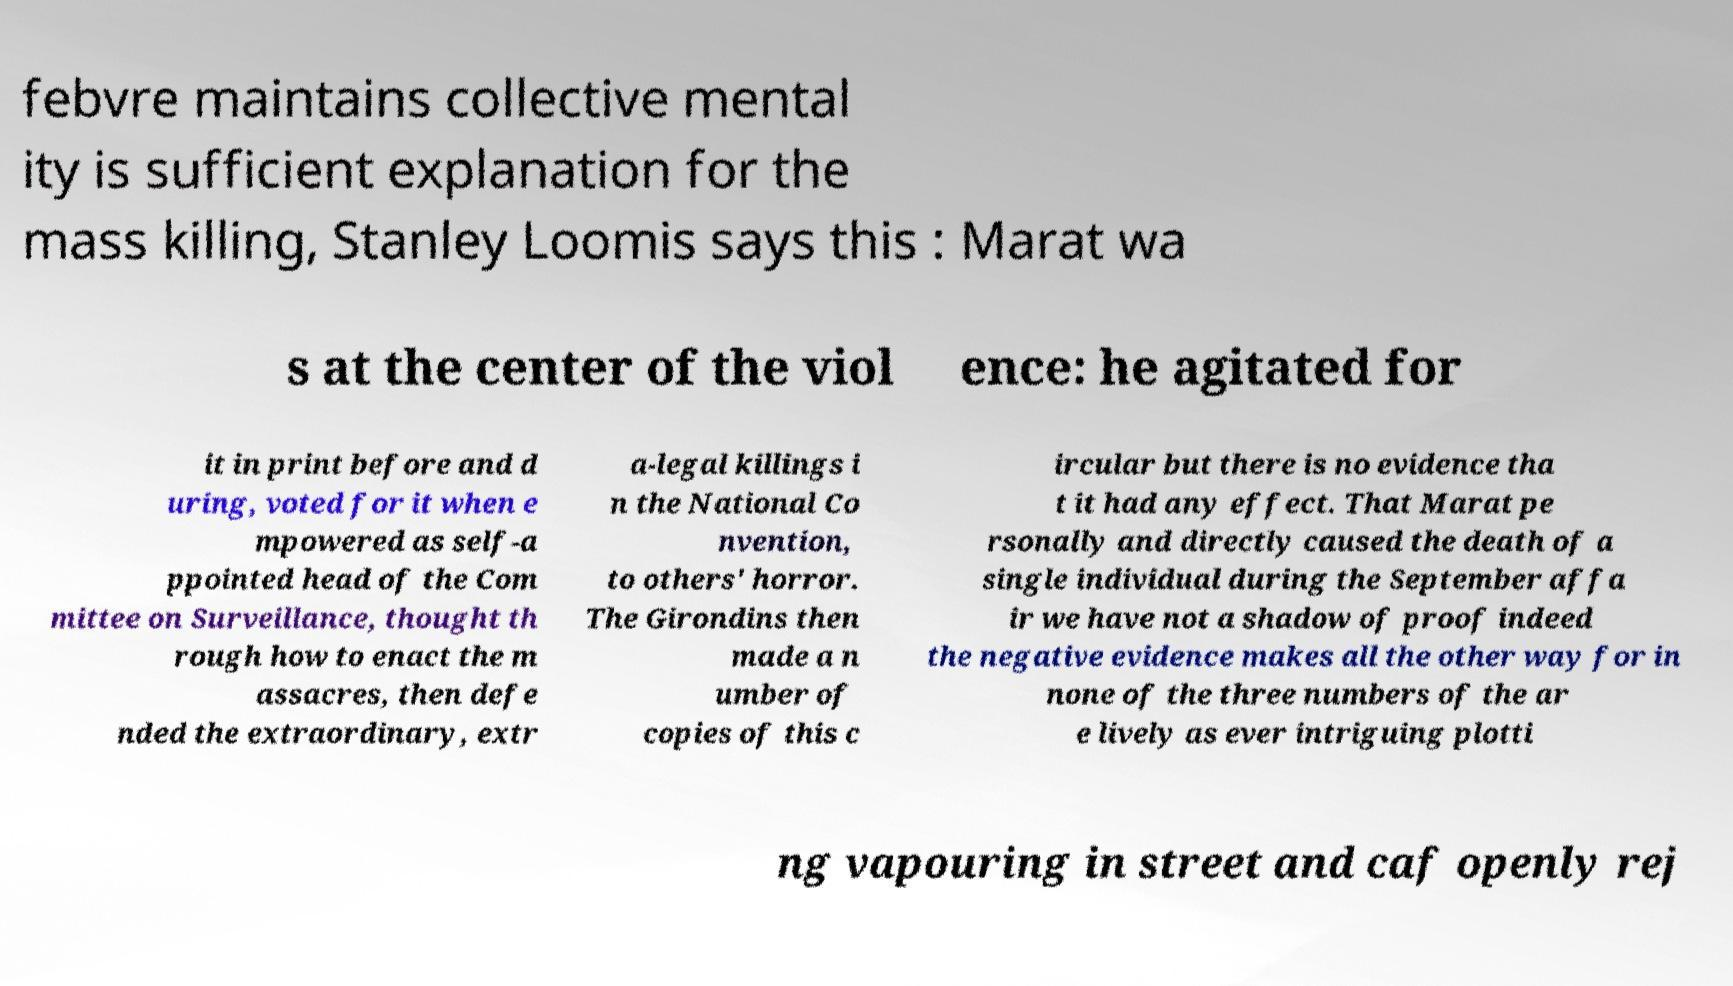Can you read and provide the text displayed in the image?This photo seems to have some interesting text. Can you extract and type it out for me? febvre maintains collective mental ity is sufficient explanation for the mass killing, Stanley Loomis says this : Marat wa s at the center of the viol ence: he agitated for it in print before and d uring, voted for it when e mpowered as self-a ppointed head of the Com mittee on Surveillance, thought th rough how to enact the m assacres, then defe nded the extraordinary, extr a-legal killings i n the National Co nvention, to others' horror. The Girondins then made a n umber of copies of this c ircular but there is no evidence tha t it had any effect. That Marat pe rsonally and directly caused the death of a single individual during the September affa ir we have not a shadow of proof indeed the negative evidence makes all the other way for in none of the three numbers of the ar e lively as ever intriguing plotti ng vapouring in street and caf openly rej 